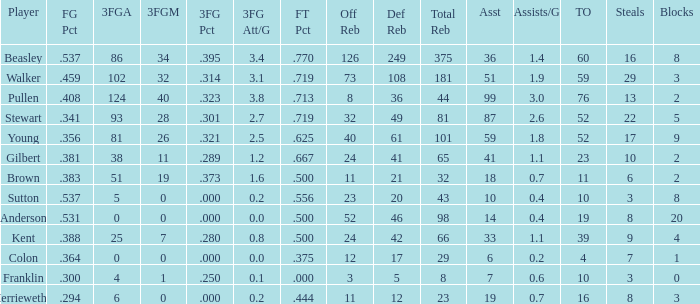How many FG percent values are associated with 59 assists and offensive rebounds under 40? 0.0. 